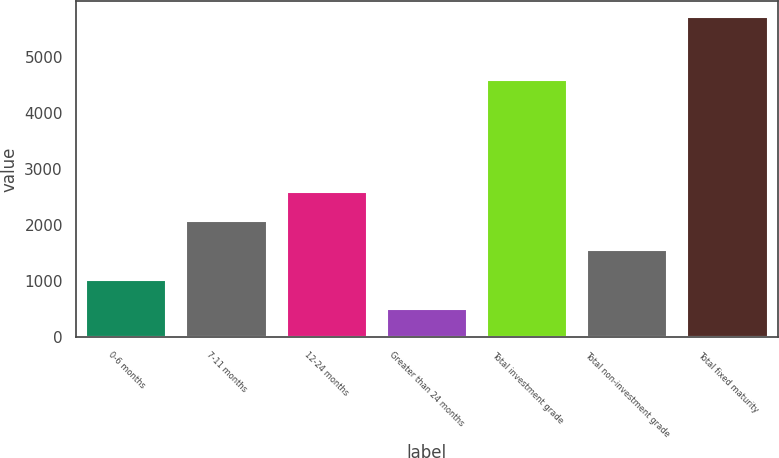Convert chart to OTSL. <chart><loc_0><loc_0><loc_500><loc_500><bar_chart><fcel>0-6 months<fcel>7-11 months<fcel>12-24 months<fcel>Greater than 24 months<fcel>Total investment grade<fcel>Total non-investment grade<fcel>Total fixed maturity<nl><fcel>1028.2<fcel>2066.6<fcel>2585.8<fcel>509<fcel>4584<fcel>1547.4<fcel>5701<nl></chart> 